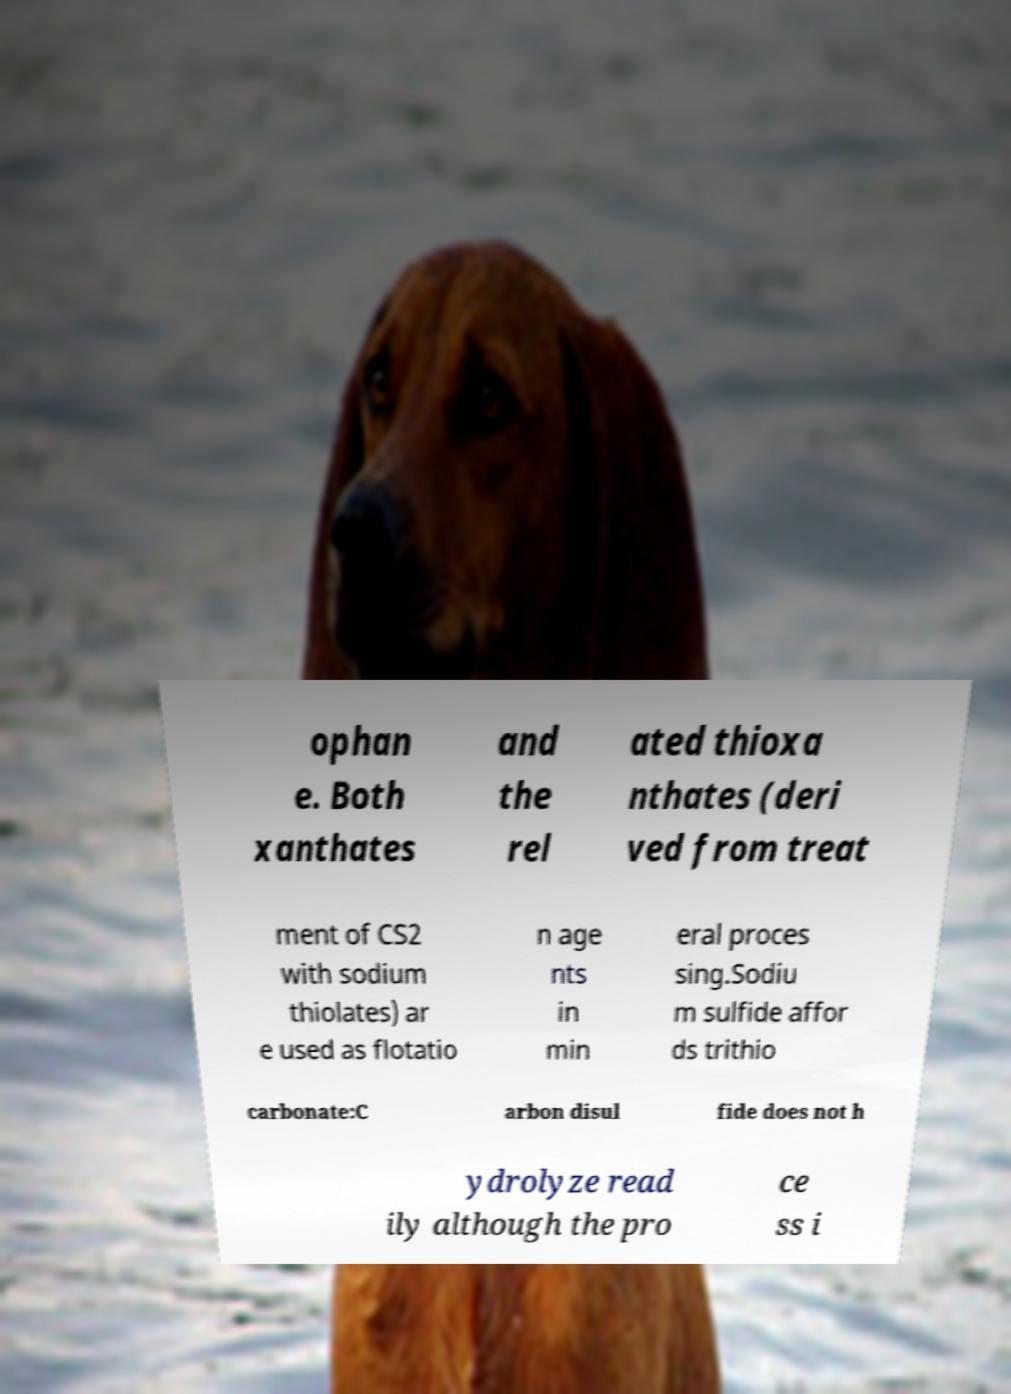There's text embedded in this image that I need extracted. Can you transcribe it verbatim? ophan e. Both xanthates and the rel ated thioxa nthates (deri ved from treat ment of CS2 with sodium thiolates) ar e used as flotatio n age nts in min eral proces sing.Sodiu m sulfide affor ds trithio carbonate:C arbon disul fide does not h ydrolyze read ily although the pro ce ss i 